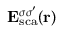<formula> <loc_0><loc_0><loc_500><loc_500>{ E } _ { s c a } ^ { \sigma \sigma ^ { \prime } } ( { r } )</formula> 